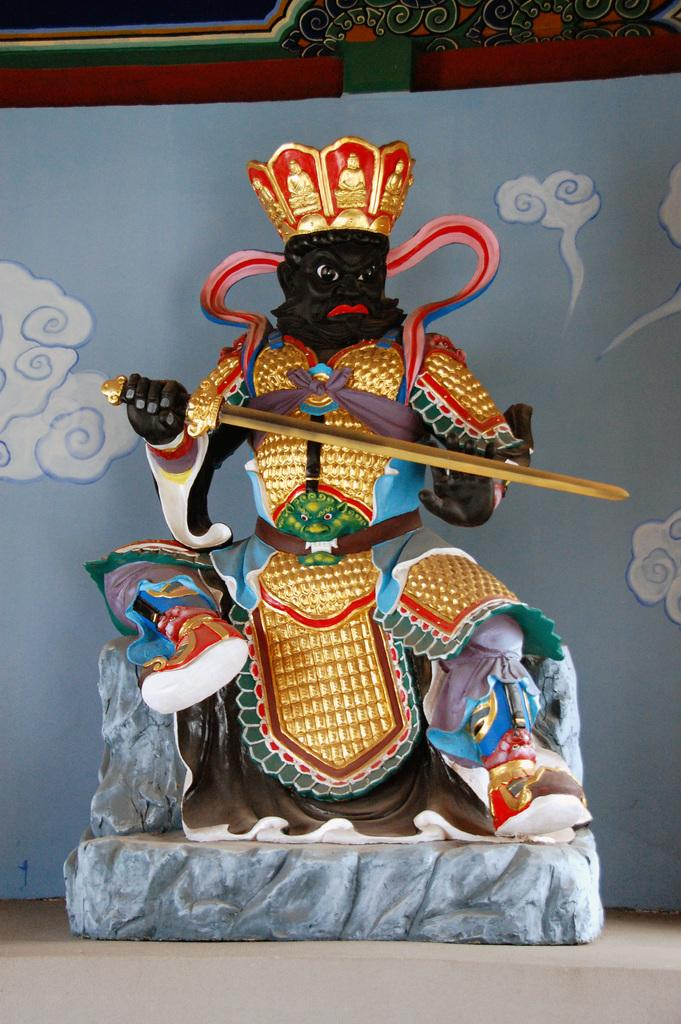What is the main subject in the center of the image? There is a statue in the center of the image. How is the statue positioned in the image? The statue is placed on the ground. What can be seen in the background of the image? There is a wall in the background of the image. What color is the crayon used to draw on the statue in the image? There is no crayon or drawing present on the statue in the image. 